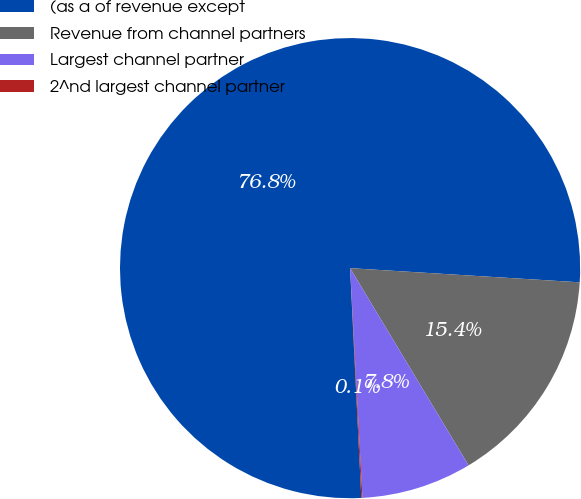Convert chart. <chart><loc_0><loc_0><loc_500><loc_500><pie_chart><fcel>(as a of revenue except<fcel>Revenue from channel partners<fcel>Largest channel partner<fcel>2^nd largest channel partner<nl><fcel>76.76%<fcel>15.41%<fcel>7.75%<fcel>0.08%<nl></chart> 